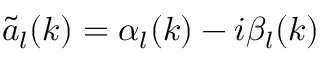Convert formula to latex. <formula><loc_0><loc_0><loc_500><loc_500>\tilde { a } _ { l } ( k ) = \alpha _ { l } ( k ) - i \beta _ { l } ( k )</formula> 